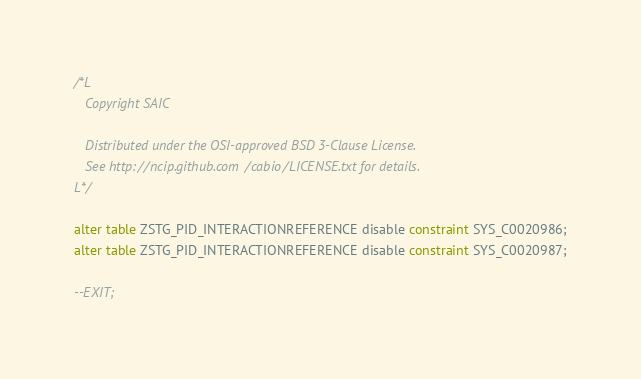<code> <loc_0><loc_0><loc_500><loc_500><_SQL_>/*L
   Copyright SAIC

   Distributed under the OSI-approved BSD 3-Clause License.
   See http://ncip.github.com/cabio/LICENSE.txt for details.
L*/

alter table ZSTG_PID_INTERACTIONREFERENCE disable constraint SYS_C0020986;
alter table ZSTG_PID_INTERACTIONREFERENCE disable constraint SYS_C0020987;

--EXIT;
</code> 